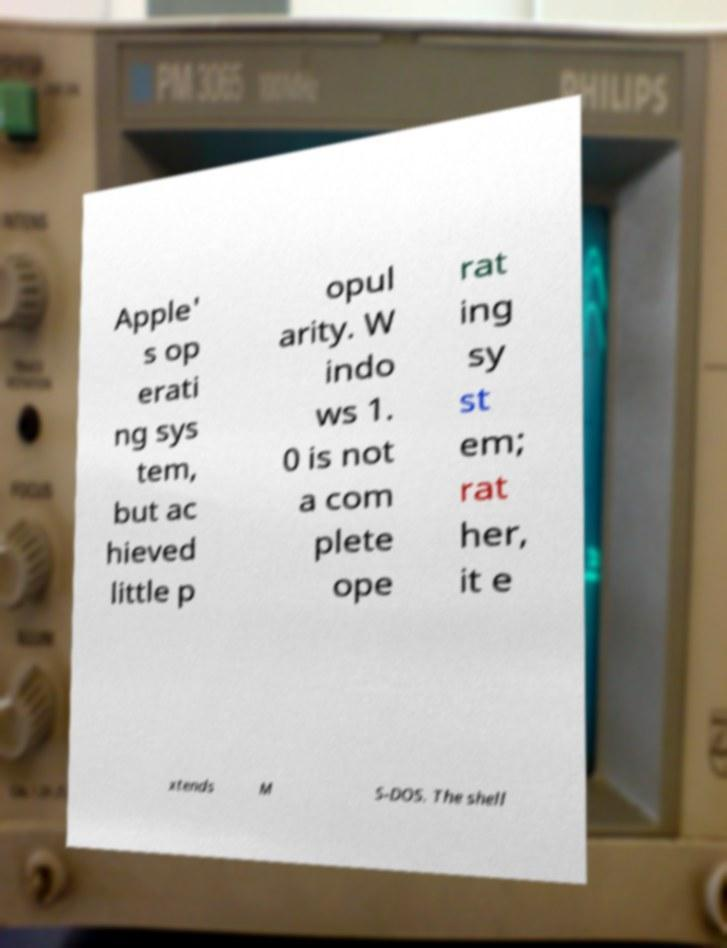Could you assist in decoding the text presented in this image and type it out clearly? Apple' s op erati ng sys tem, but ac hieved little p opul arity. W indo ws 1. 0 is not a com plete ope rat ing sy st em; rat her, it e xtends M S-DOS. The shell 